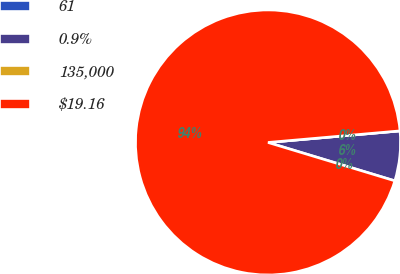Convert chart to OTSL. <chart><loc_0><loc_0><loc_500><loc_500><pie_chart><fcel>61<fcel>0.9%<fcel>135,000<fcel>$19.16<nl><fcel>0.0%<fcel>6.07%<fcel>0.0%<fcel>93.93%<nl></chart> 